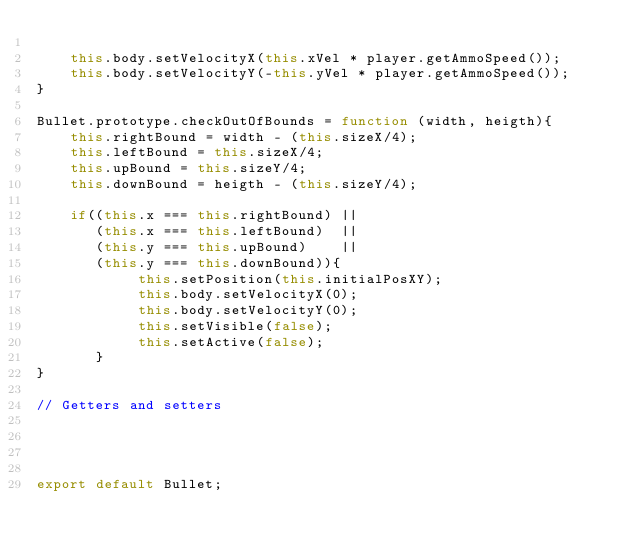<code> <loc_0><loc_0><loc_500><loc_500><_JavaScript_>    
    this.body.setVelocityX(this.xVel * player.getAmmoSpeed());
    this.body.setVelocityY(-this.yVel * player.getAmmoSpeed());
}

Bullet.prototype.checkOutOfBounds = function (width, heigth){
    this.rightBound = width - (this.sizeX/4);
    this.leftBound = this.sizeX/4;
    this.upBound = this.sizeY/4;
    this.downBound = heigth - (this.sizeY/4);

    if((this.x === this.rightBound) || 
       (this.x === this.leftBound)  || 
       (this.y === this.upBound)    || 
       (this.y === this.downBound)){
            this.setPosition(this.initialPosXY);
            this.body.setVelocityX(0);
            this.body.setVelocityY(0);
            this.setVisible(false);
            this.setActive(false);
       }
}

// Getters and setters




export default Bullet;
</code> 